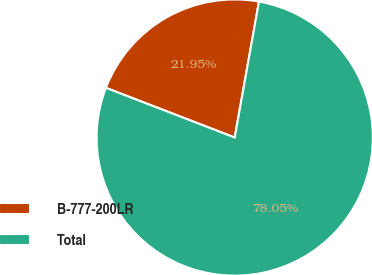Convert chart to OTSL. <chart><loc_0><loc_0><loc_500><loc_500><pie_chart><fcel>B-777-200LR<fcel>Total<nl><fcel>21.95%<fcel>78.05%<nl></chart> 